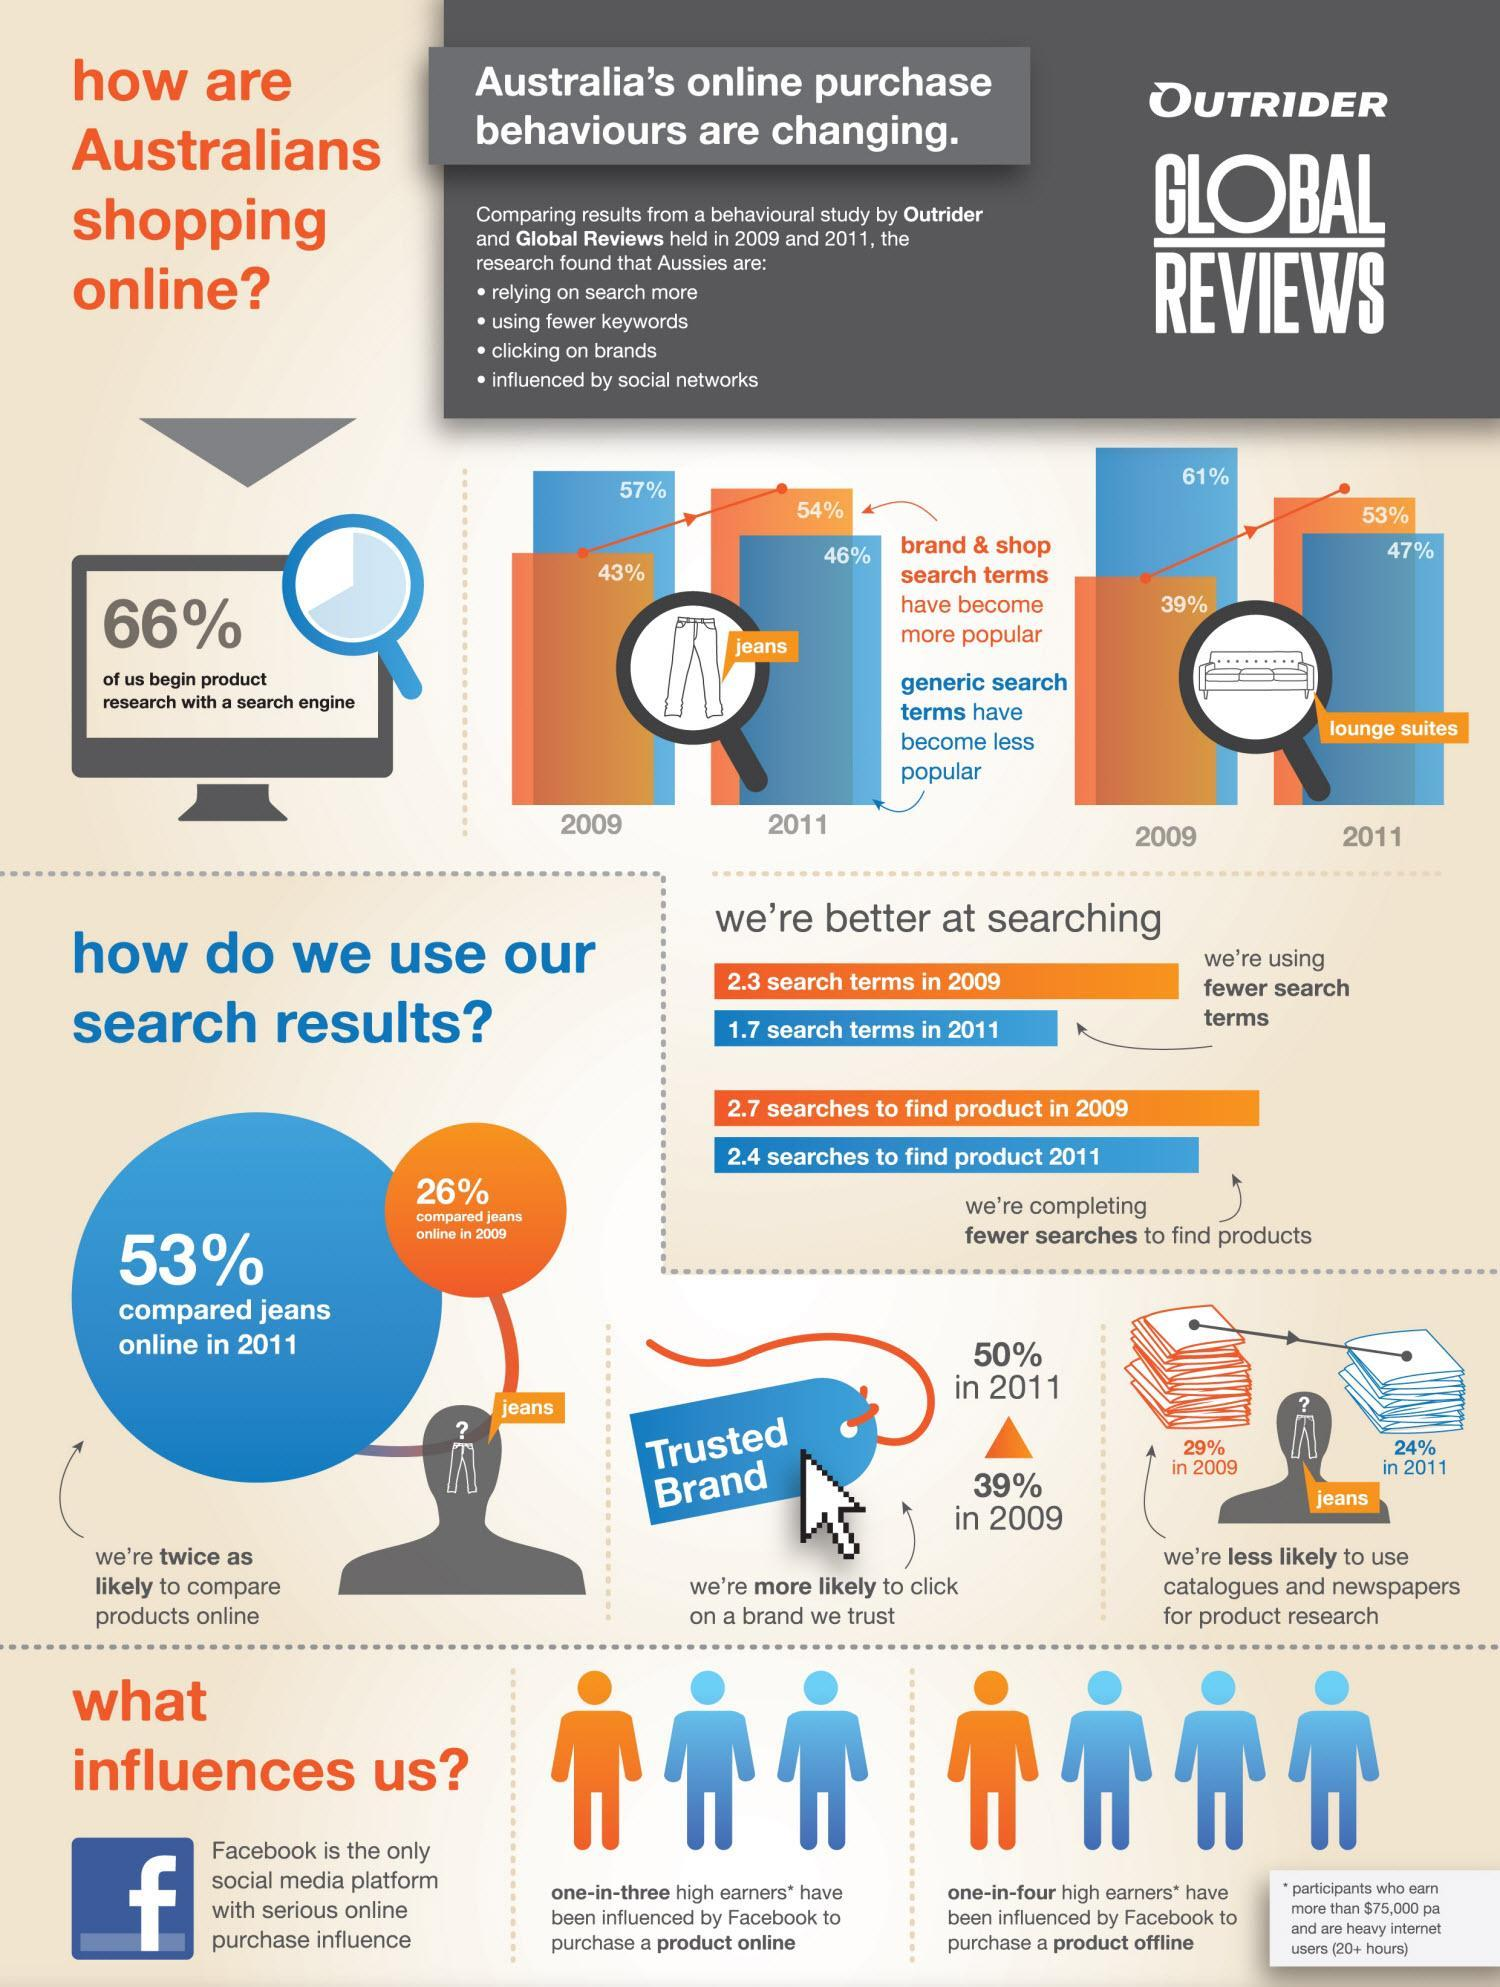A higher number of search terms were used in which year - 2009 or 2011?
Answer the question with a short phrase. 2009 Which year shows a lower percent of people doing online product comparisons - 2009 or 2011? 2009 Which type of search was more popular in 2009? generic search Which year shows higher number of searches to find products - 2009 or 2011? 2009 Which year shows lower usage of catalogues and newspapers for product research -2009 or 2011? 2011 How many of the people research a product via a search engine? 66% Which year had a higher percent of people click on a trusted brand - 2009 or 2011? 2011 What ratio of people have been influenced by Facebook to make an offline purchase? one-in-four What ratio of people have been influenced by Facebook to make an online purchase? one-in-three 